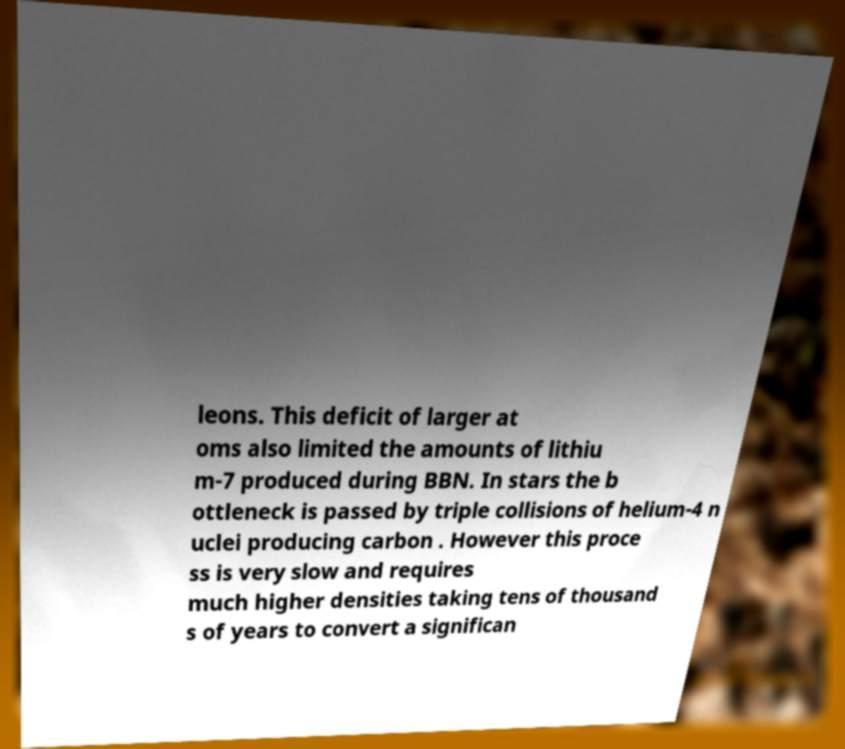Can you read and provide the text displayed in the image?This photo seems to have some interesting text. Can you extract and type it out for me? leons. This deficit of larger at oms also limited the amounts of lithiu m-7 produced during BBN. In stars the b ottleneck is passed by triple collisions of helium-4 n uclei producing carbon . However this proce ss is very slow and requires much higher densities taking tens of thousand s of years to convert a significan 